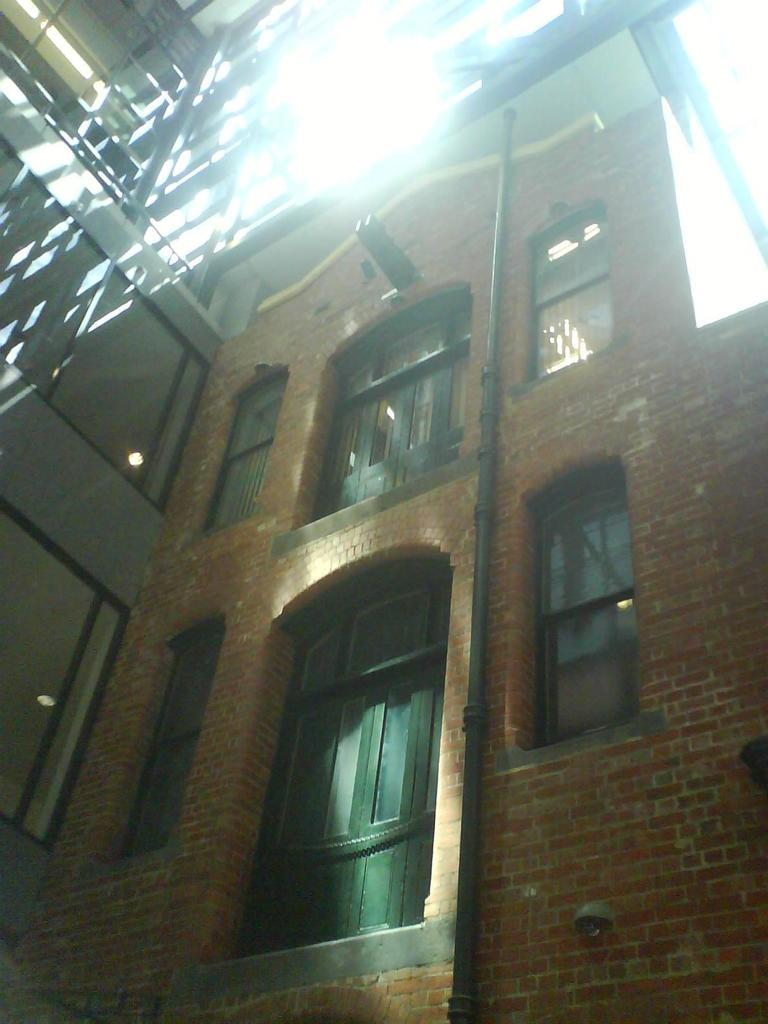What type of structure is visible in the image? There is a building in the image. What feature can be seen on the building? The building has windows. What type of cakes are being approved by the house in the image? There is no house or cakes present in the image; it only features a building with windows. 